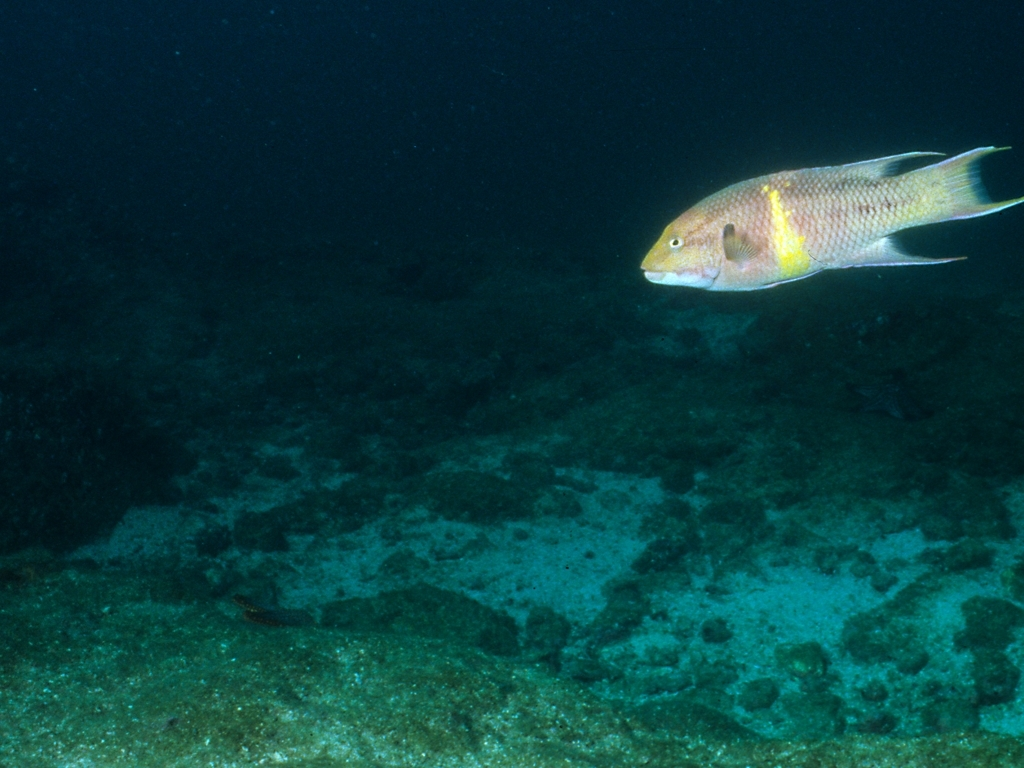What time of day does it look like this photo was taken? Given the relatively low visibility and subdued lighting in the photo, it suggests that the photo may have been taken during dusk or at a location with deeper waters where sunlight penetrates less effectively. Is it common to find fish like this alone, or do they usually swim in schools? Some wrasse species demonstrate social behavior and are commonly found in schools, especially when juvenile. However, adult wrasses are often observed swimming alone or in smaller groups, depending on the species and environmental conditions. 